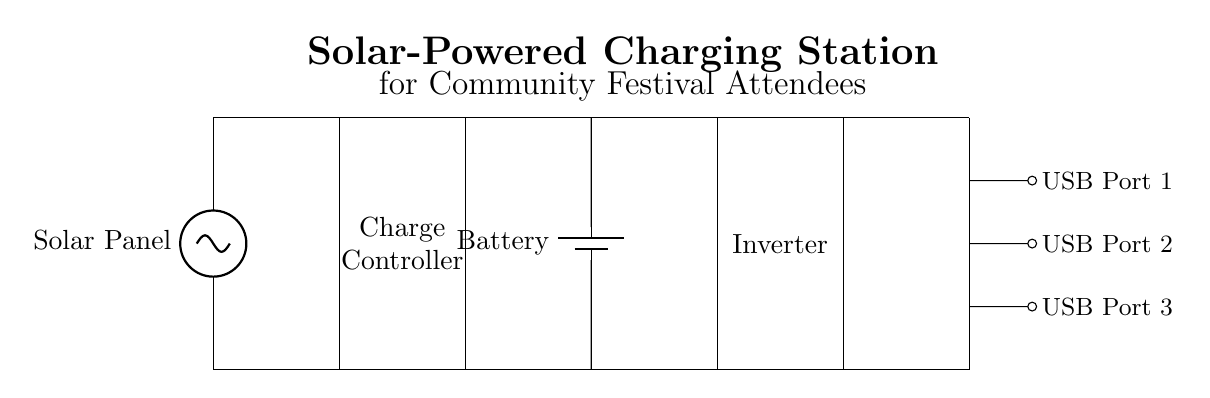What is the main power source for this circuit? The main power source is the solar panel, which converts sunlight into electrical energy for the circuit.
Answer: Solar panel What component is used to regulate the charging process in the circuit? The charge controller is used to manage and regulate the voltage and current coming from the solar panel to safely charge the battery.
Answer: Charge controller How many USB charging ports are available for use in this charging station? The circuit diagram shows three USB charging ports, labeled as USB Port 1, USB Port 2, and USB Port 3, allowing multiple devices to be charged simultaneously.
Answer: Three Which component converts the stored energy in the battery back into usable power for charging devices? The inverter is responsible for converting the direct current stored in the battery into alternating current, which is compatible with various devices requiring such power input.
Answer: Inverter What is the purpose of the battery in this circuit? The battery acts as a storage unit, holding the energy generated by the solar panel for later use, ensuring that devices can be charged even when sunlight is not available.
Answer: Storage unit 